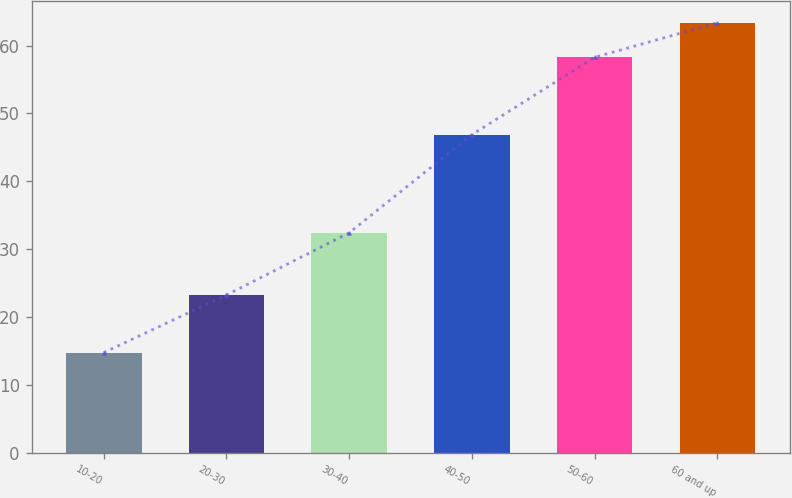<chart> <loc_0><loc_0><loc_500><loc_500><bar_chart><fcel>10-20<fcel>20-30<fcel>30-40<fcel>40-50<fcel>50-60<fcel>60 and up<nl><fcel>14.75<fcel>23.23<fcel>32.4<fcel>46.86<fcel>58.27<fcel>63.34<nl></chart> 